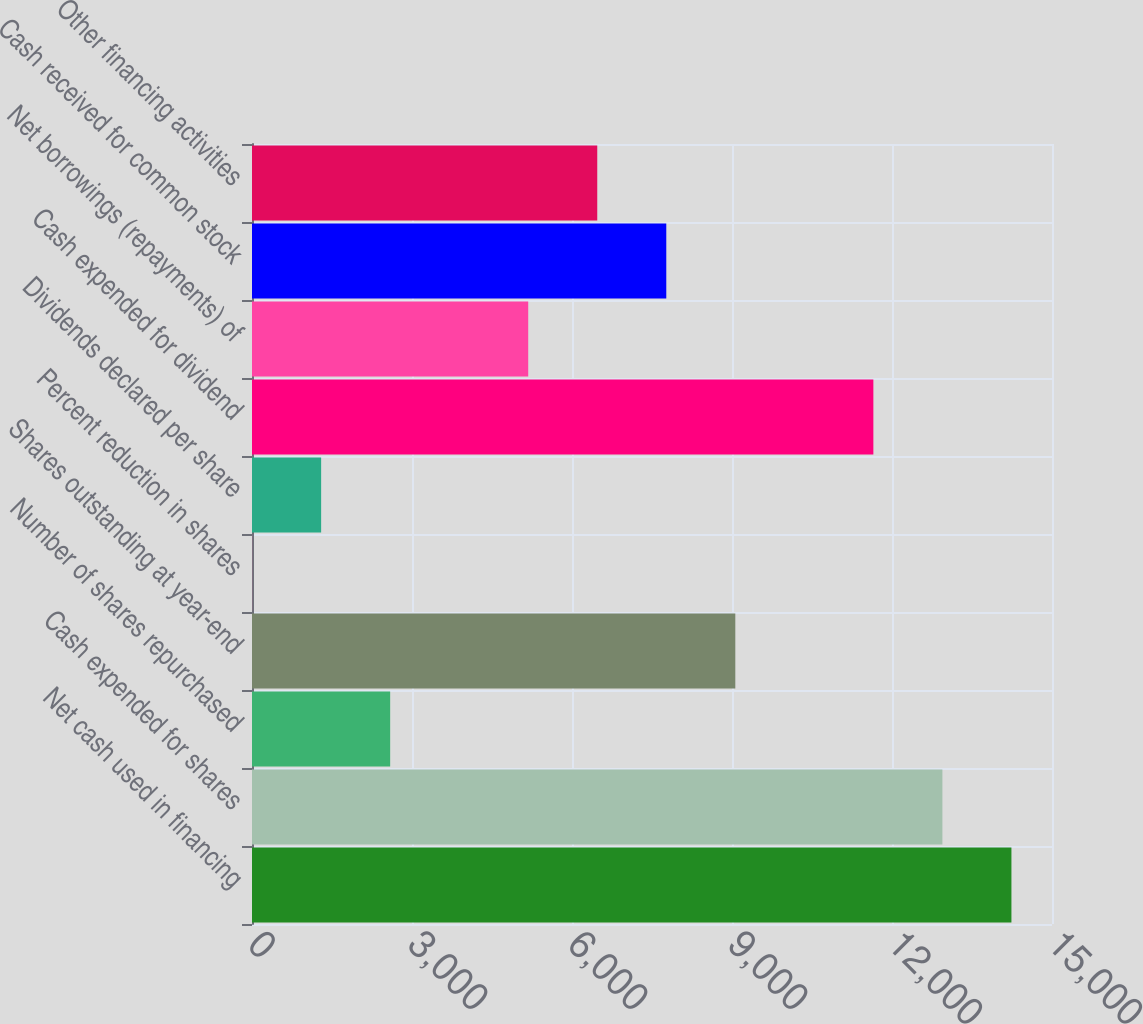Convert chart. <chart><loc_0><loc_0><loc_500><loc_500><bar_chart><fcel>Net cash used in financing<fcel>Cash expended for shares<fcel>Number of shares repurchased<fcel>Shares outstanding at year-end<fcel>Percent reduction in shares<fcel>Dividends declared per share<fcel>Cash expended for dividend<fcel>Net borrowings (repayments) of<fcel>Cash received for common stock<fcel>Other financing activities<nl><fcel>14239.3<fcel>12945<fcel>2590.6<fcel>9062.1<fcel>2<fcel>1296.3<fcel>11650.7<fcel>5179.2<fcel>7767.8<fcel>6473.5<nl></chart> 